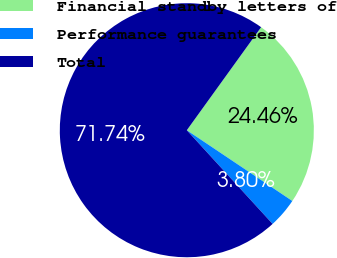<chart> <loc_0><loc_0><loc_500><loc_500><pie_chart><fcel>Financial standby letters of<fcel>Performance guarantees<fcel>Total<nl><fcel>24.46%<fcel>3.8%<fcel>71.74%<nl></chart> 